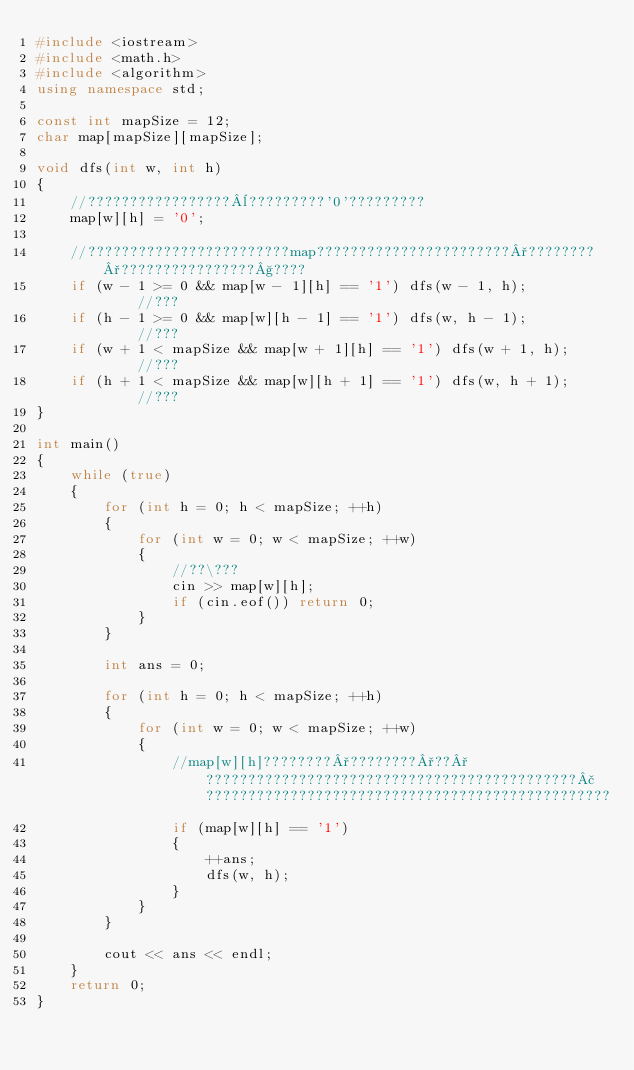Convert code to text. <code><loc_0><loc_0><loc_500><loc_500><_C++_>#include <iostream>
#include <math.h>
#include <algorithm>
using namespace std;

const int mapSize = 12;
char map[mapSize][mapSize];

void dfs(int w, int h)
{
	//?????????????????¨?????????'0'?????????
	map[w][h] = '0';

	//????????????????????????map???????????????????????°????????°????????????????§????
	if (w - 1 >= 0 && map[w - 1][h] == '1') dfs(w - 1, h);			//???
	if (h - 1 >= 0 && map[w][h - 1] == '1') dfs(w, h - 1);			//???
	if (w + 1 < mapSize && map[w + 1][h] == '1') dfs(w + 1, h);		//???
	if (h + 1 < mapSize && map[w][h + 1] == '1') dfs(w, h + 1);		//???
}

int main()
{
	while (true)
	{
		for (int h = 0; h < mapSize; ++h)
		{
			for (int w = 0; w < mapSize; ++w)
			{
				//??\???
				cin >> map[w][h];
				if (cin.eof()) return 0;
			}
		}

		int ans = 0;

		for (int h = 0; h < mapSize; ++h)
		{
			for (int w = 0; w < mapSize; ++w)
			{
				//map[w][h]????????°????????°??°????????????????????????????????????????????£????????????????????????????????????????????????
				if (map[w][h] == '1')
				{
					++ans;
					dfs(w, h);
				}
			}
		}

		cout << ans << endl;
	}
	return 0;
}</code> 